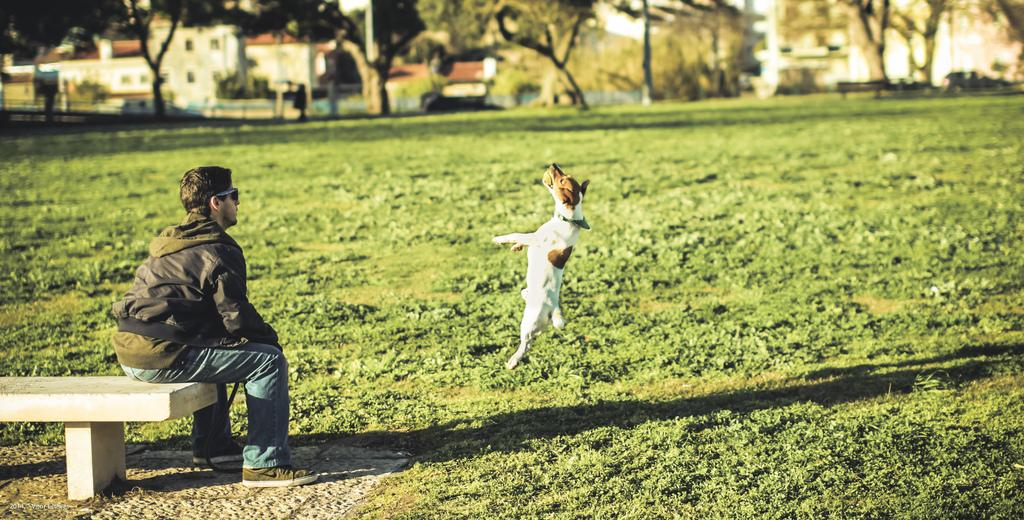What is the person in the image doing? There is a person sitting on a bench in the image. What animal is present in the image? There is a dog in the image. What action is the dog performing? The dog is jumping and in the air in the image. What type of natural environment can be seen in the image? There are trees visible in the image. What type of man-made structures can be seen in the image? There are buildings visible in the image. What type of chair is the dog sitting on in the image? There is no chair present in the image, and the dog is not sitting on one; it is jumping and in the air. What type of stick is the person holding in the image? There is no stick present in the image, and the person is not holding one; they are sitting on a bench. 